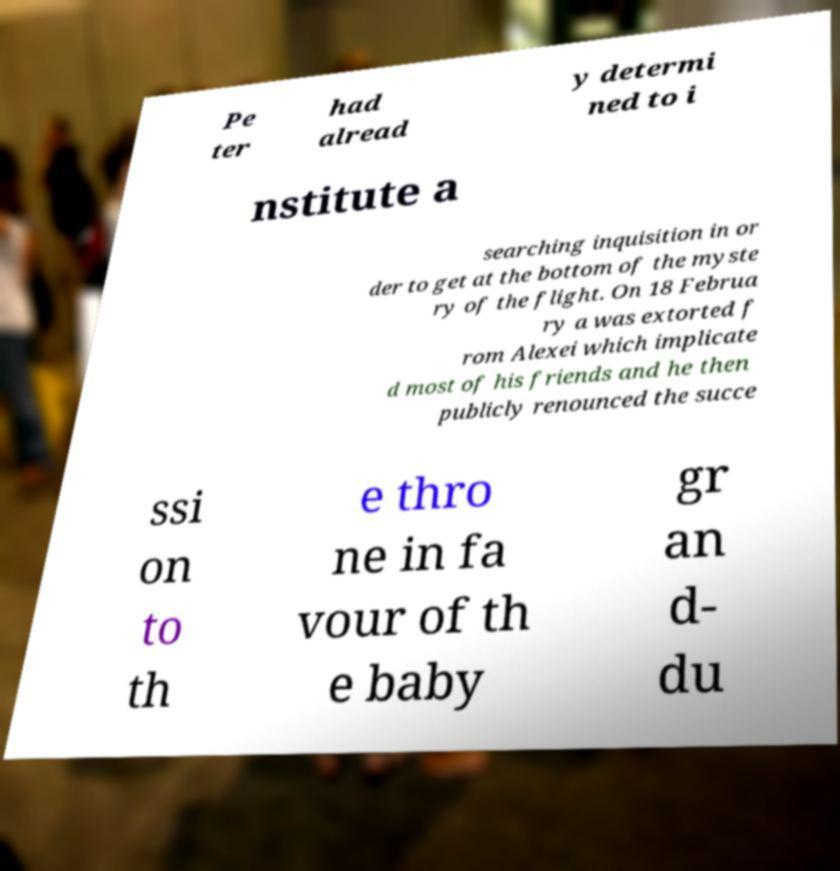Could you assist in decoding the text presented in this image and type it out clearly? Pe ter had alread y determi ned to i nstitute a searching inquisition in or der to get at the bottom of the myste ry of the flight. On 18 Februa ry a was extorted f rom Alexei which implicate d most of his friends and he then publicly renounced the succe ssi on to th e thro ne in fa vour of th e baby gr an d- du 